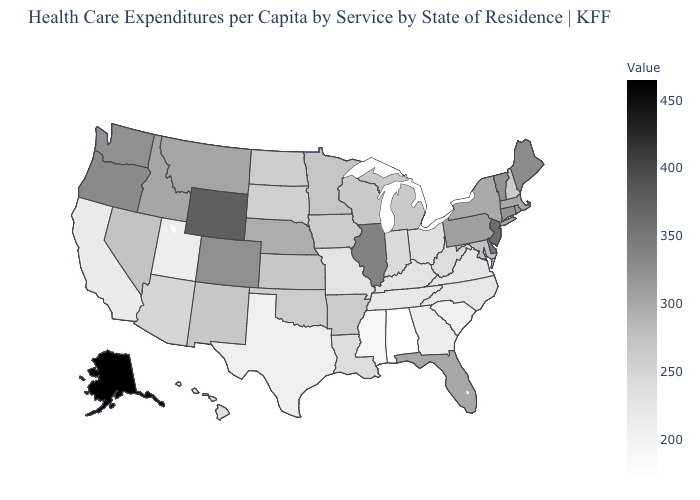Which states hav the highest value in the South?
Concise answer only. Delaware. Does Hawaii have a higher value than Nevada?
Short answer required. No. 